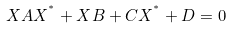Convert formula to latex. <formula><loc_0><loc_0><loc_500><loc_500>X A X ^ { ^ { * } } + X B + C X ^ { ^ { * } } + D = 0</formula> 